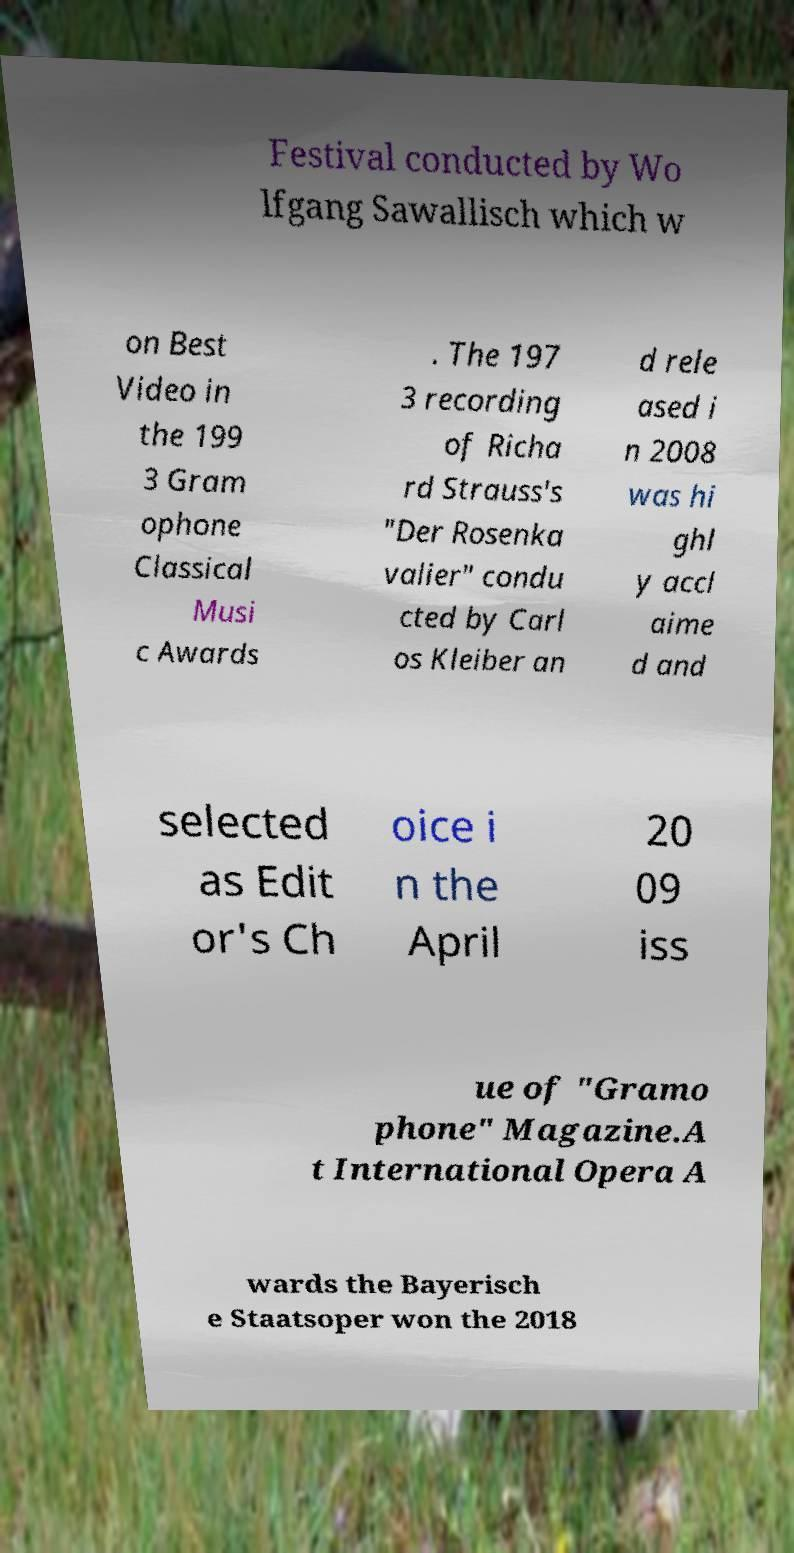Can you accurately transcribe the text from the provided image for me? Festival conducted by Wo lfgang Sawallisch which w on Best Video in the 199 3 Gram ophone Classical Musi c Awards . The 197 3 recording of Richa rd Strauss's "Der Rosenka valier" condu cted by Carl os Kleiber an d rele ased i n 2008 was hi ghl y accl aime d and selected as Edit or's Ch oice i n the April 20 09 iss ue of "Gramo phone" Magazine.A t International Opera A wards the Bayerisch e Staatsoper won the 2018 